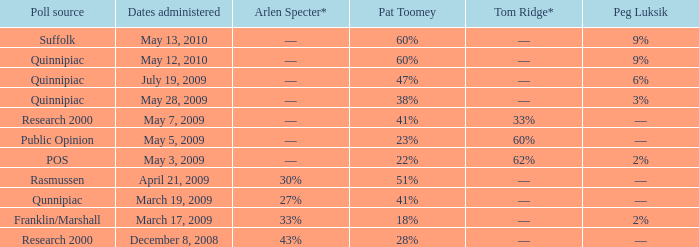Which Dates administered has an Arlen Specter* of ––, and a Peg Luksik of 9%? May 13, 2010, May 12, 2010. 